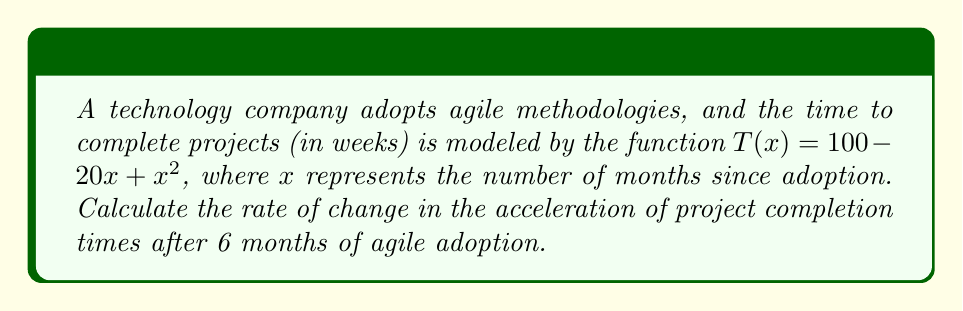Solve this math problem. Let's approach this step-by-step:

1) The function $T(x) = 100 - 20x + x^2$ represents the time to complete projects.

2) To find the acceleration, we need the second derivative of $T(x)$.

3) First, let's find the first derivative:
   $T'(x) = -20 + 2x$

4) Now, let's find the second derivative:
   $T''(x) = 2$

5) The second derivative represents the acceleration of project completion times.

6) Since $T''(x) = 2$, the acceleration is constant at 2 weeks per month squared.

7) The question asks for the rate of change in acceleration after 6 months.

8) Since the acceleration is constant (the second derivative is a constant), the rate of change of acceleration is zero.
Answer: $0$ weeks/month³ 